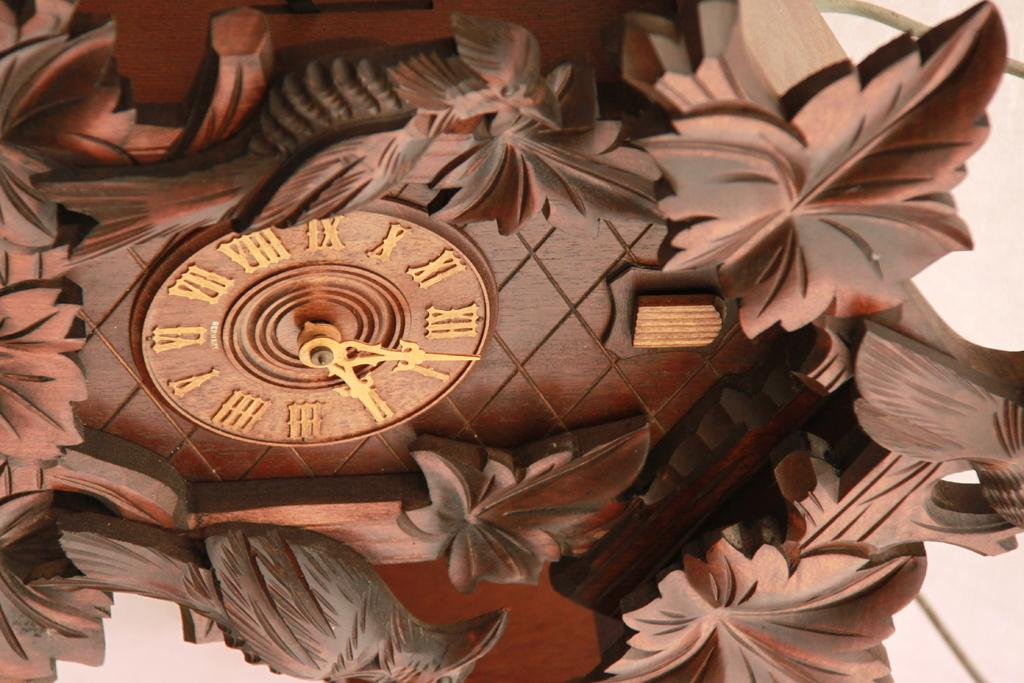Provide a one-sentence caption for the provided image. A beautifully carved wooden clock shows the time is a little after 2:00. 